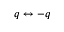<formula> <loc_0><loc_0><loc_500><loc_500>q \leftrightarrow - q</formula> 